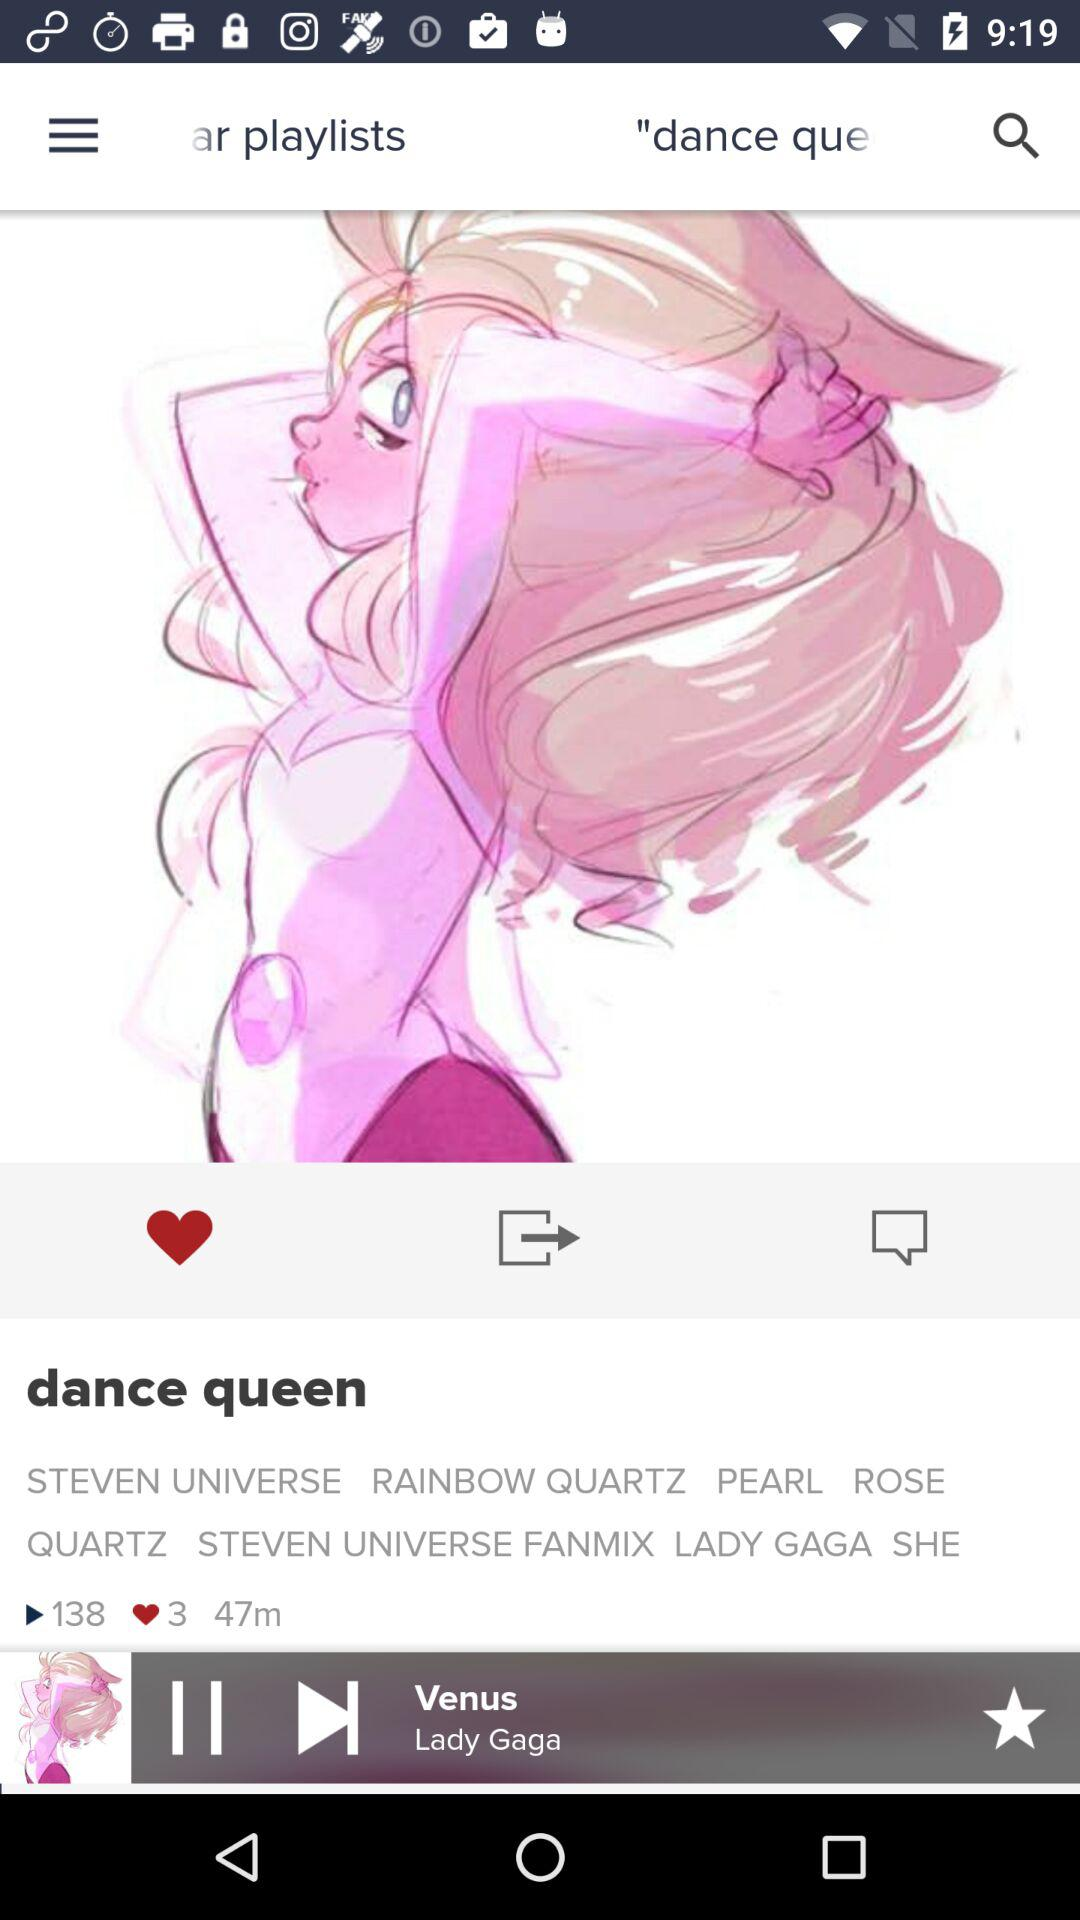What's the current playing song? The current playing song is "Venus". 